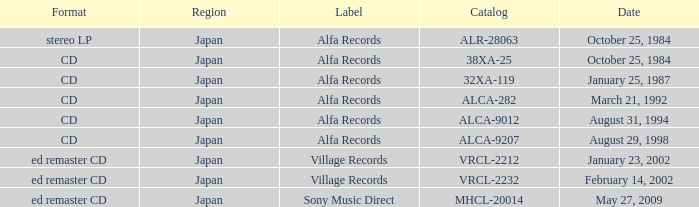What Label released on October 25, 1984, in the format of Stereo LP? Alfa Records. 